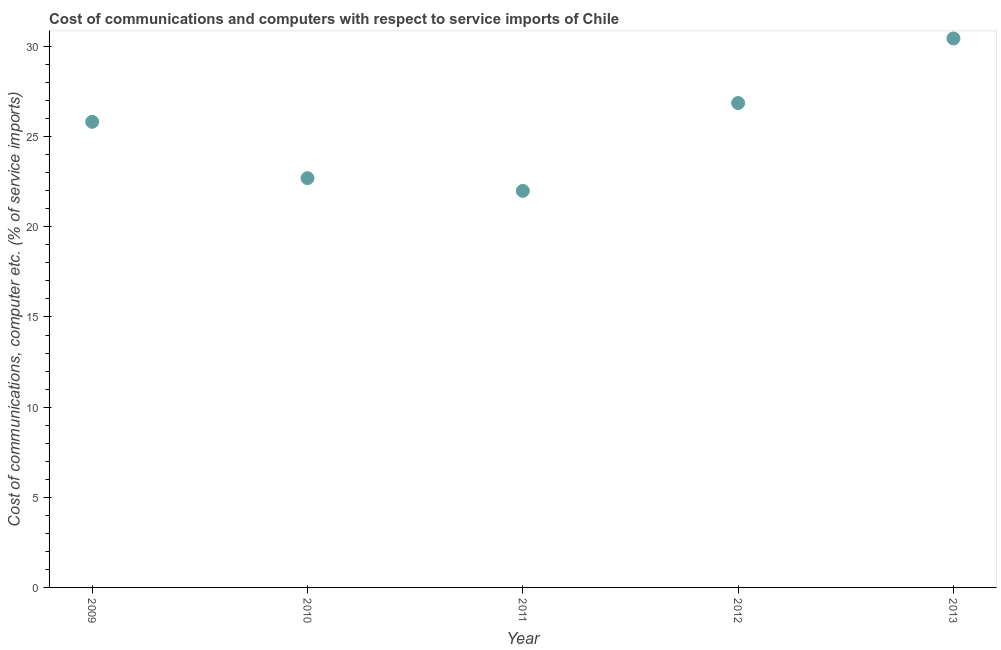What is the cost of communications and computer in 2013?
Your response must be concise. 30.45. Across all years, what is the maximum cost of communications and computer?
Provide a succinct answer. 30.45. Across all years, what is the minimum cost of communications and computer?
Your answer should be compact. 21.99. In which year was the cost of communications and computer minimum?
Provide a succinct answer. 2011. What is the sum of the cost of communications and computer?
Provide a short and direct response. 127.83. What is the difference between the cost of communications and computer in 2011 and 2013?
Your answer should be very brief. -8.45. What is the average cost of communications and computer per year?
Keep it short and to the point. 25.57. What is the median cost of communications and computer?
Keep it short and to the point. 25.83. In how many years, is the cost of communications and computer greater than 12 %?
Your answer should be compact. 5. What is the ratio of the cost of communications and computer in 2012 to that in 2013?
Offer a very short reply. 0.88. What is the difference between the highest and the second highest cost of communications and computer?
Offer a very short reply. 3.58. What is the difference between the highest and the lowest cost of communications and computer?
Your answer should be very brief. 8.45. Does the cost of communications and computer monotonically increase over the years?
Give a very brief answer. No. How many dotlines are there?
Your response must be concise. 1. How many years are there in the graph?
Offer a very short reply. 5. Are the values on the major ticks of Y-axis written in scientific E-notation?
Your response must be concise. No. What is the title of the graph?
Make the answer very short. Cost of communications and computers with respect to service imports of Chile. What is the label or title of the X-axis?
Your response must be concise. Year. What is the label or title of the Y-axis?
Provide a succinct answer. Cost of communications, computer etc. (% of service imports). What is the Cost of communications, computer etc. (% of service imports) in 2009?
Offer a terse response. 25.83. What is the Cost of communications, computer etc. (% of service imports) in 2010?
Make the answer very short. 22.7. What is the Cost of communications, computer etc. (% of service imports) in 2011?
Offer a terse response. 21.99. What is the Cost of communications, computer etc. (% of service imports) in 2012?
Offer a terse response. 26.87. What is the Cost of communications, computer etc. (% of service imports) in 2013?
Give a very brief answer. 30.45. What is the difference between the Cost of communications, computer etc. (% of service imports) in 2009 and 2010?
Your answer should be compact. 3.12. What is the difference between the Cost of communications, computer etc. (% of service imports) in 2009 and 2011?
Provide a short and direct response. 3.83. What is the difference between the Cost of communications, computer etc. (% of service imports) in 2009 and 2012?
Provide a succinct answer. -1.04. What is the difference between the Cost of communications, computer etc. (% of service imports) in 2009 and 2013?
Provide a short and direct response. -4.62. What is the difference between the Cost of communications, computer etc. (% of service imports) in 2010 and 2011?
Provide a succinct answer. 0.71. What is the difference between the Cost of communications, computer etc. (% of service imports) in 2010 and 2012?
Ensure brevity in your answer.  -4.16. What is the difference between the Cost of communications, computer etc. (% of service imports) in 2010 and 2013?
Give a very brief answer. -7.75. What is the difference between the Cost of communications, computer etc. (% of service imports) in 2011 and 2012?
Ensure brevity in your answer.  -4.87. What is the difference between the Cost of communications, computer etc. (% of service imports) in 2011 and 2013?
Your answer should be compact. -8.45. What is the difference between the Cost of communications, computer etc. (% of service imports) in 2012 and 2013?
Your response must be concise. -3.58. What is the ratio of the Cost of communications, computer etc. (% of service imports) in 2009 to that in 2010?
Your answer should be very brief. 1.14. What is the ratio of the Cost of communications, computer etc. (% of service imports) in 2009 to that in 2011?
Offer a terse response. 1.17. What is the ratio of the Cost of communications, computer etc. (% of service imports) in 2009 to that in 2013?
Make the answer very short. 0.85. What is the ratio of the Cost of communications, computer etc. (% of service imports) in 2010 to that in 2011?
Offer a very short reply. 1.03. What is the ratio of the Cost of communications, computer etc. (% of service imports) in 2010 to that in 2012?
Make the answer very short. 0.84. What is the ratio of the Cost of communications, computer etc. (% of service imports) in 2010 to that in 2013?
Provide a short and direct response. 0.75. What is the ratio of the Cost of communications, computer etc. (% of service imports) in 2011 to that in 2012?
Your answer should be very brief. 0.82. What is the ratio of the Cost of communications, computer etc. (% of service imports) in 2011 to that in 2013?
Provide a short and direct response. 0.72. What is the ratio of the Cost of communications, computer etc. (% of service imports) in 2012 to that in 2013?
Offer a terse response. 0.88. 